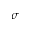Convert formula to latex. <formula><loc_0><loc_0><loc_500><loc_500>\sigma</formula> 